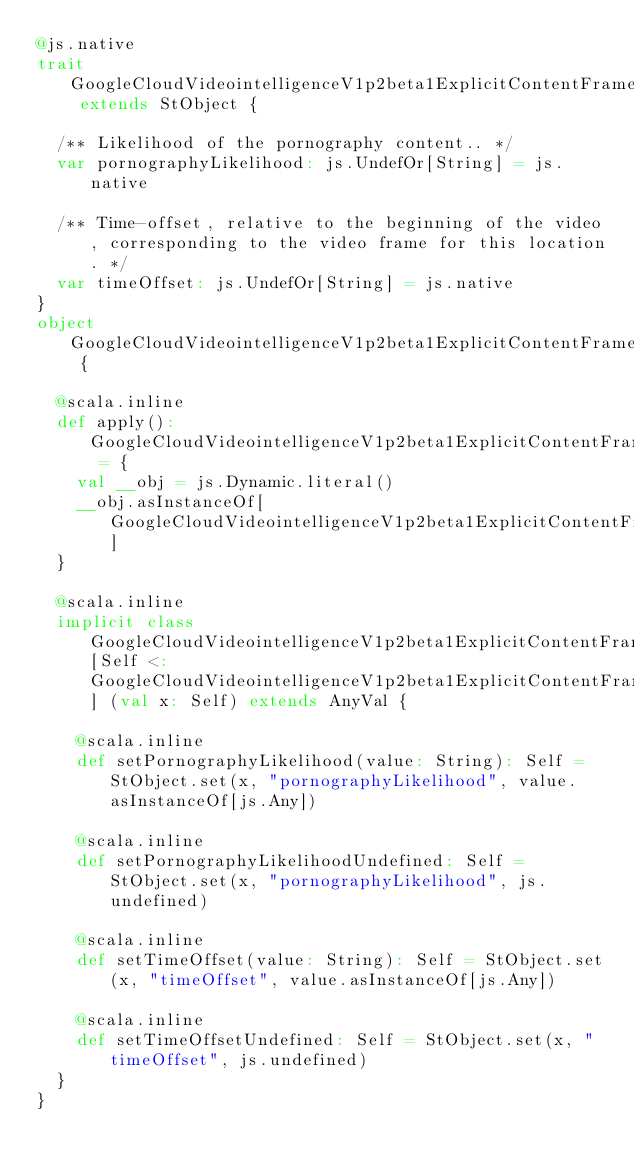<code> <loc_0><loc_0><loc_500><loc_500><_Scala_>@js.native
trait GoogleCloudVideointelligenceV1p2beta1ExplicitContentFrame extends StObject {
  
  /** Likelihood of the pornography content.. */
  var pornographyLikelihood: js.UndefOr[String] = js.native
  
  /** Time-offset, relative to the beginning of the video, corresponding to the video frame for this location. */
  var timeOffset: js.UndefOr[String] = js.native
}
object GoogleCloudVideointelligenceV1p2beta1ExplicitContentFrame {
  
  @scala.inline
  def apply(): GoogleCloudVideointelligenceV1p2beta1ExplicitContentFrame = {
    val __obj = js.Dynamic.literal()
    __obj.asInstanceOf[GoogleCloudVideointelligenceV1p2beta1ExplicitContentFrame]
  }
  
  @scala.inline
  implicit class GoogleCloudVideointelligenceV1p2beta1ExplicitContentFrameMutableBuilder[Self <: GoogleCloudVideointelligenceV1p2beta1ExplicitContentFrame] (val x: Self) extends AnyVal {
    
    @scala.inline
    def setPornographyLikelihood(value: String): Self = StObject.set(x, "pornographyLikelihood", value.asInstanceOf[js.Any])
    
    @scala.inline
    def setPornographyLikelihoodUndefined: Self = StObject.set(x, "pornographyLikelihood", js.undefined)
    
    @scala.inline
    def setTimeOffset(value: String): Self = StObject.set(x, "timeOffset", value.asInstanceOf[js.Any])
    
    @scala.inline
    def setTimeOffsetUndefined: Self = StObject.set(x, "timeOffset", js.undefined)
  }
}
</code> 